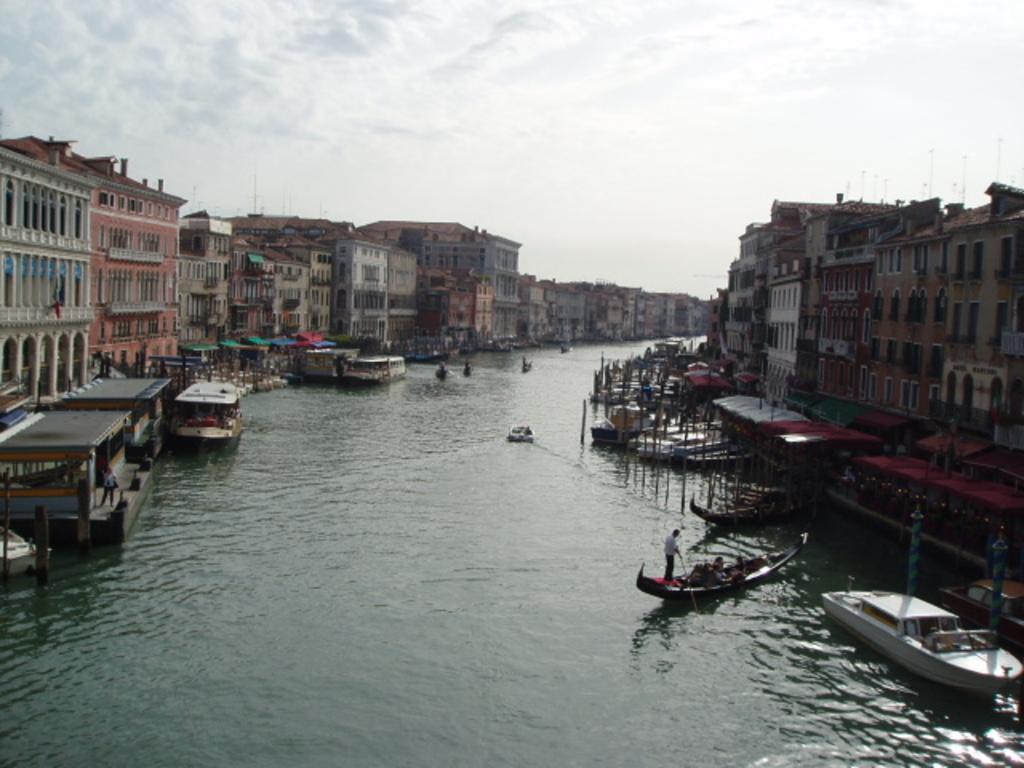Could you give a brief overview of what you see in this image? In the center of the image there are boats in the water. On both right and left side of the image there are buildings. In the background of the image there is sky. 